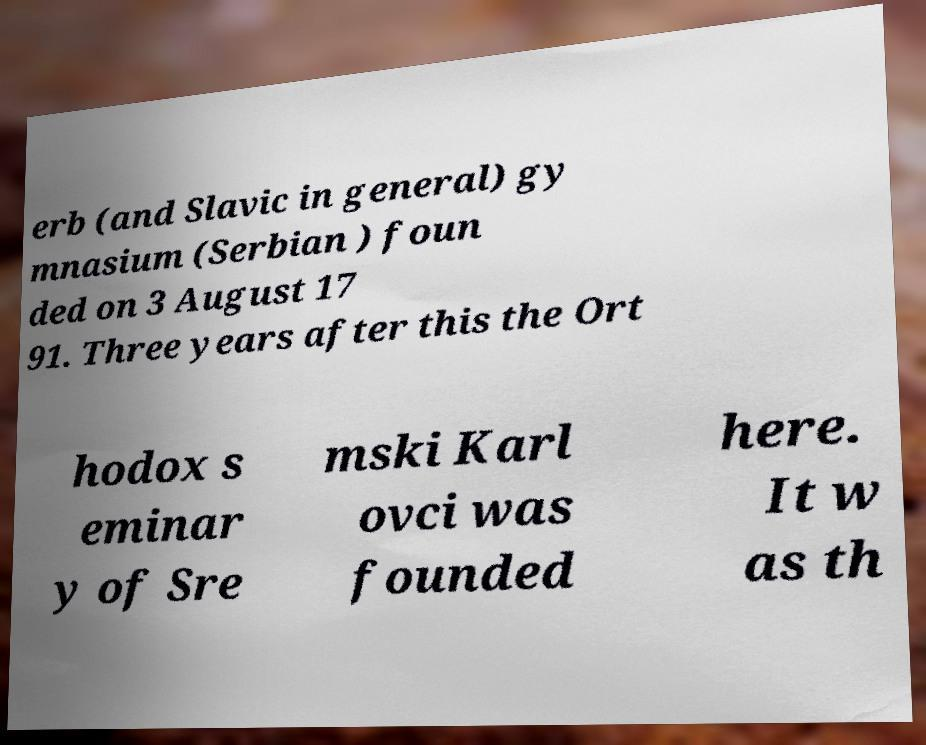I need the written content from this picture converted into text. Can you do that? erb (and Slavic in general) gy mnasium (Serbian ) foun ded on 3 August 17 91. Three years after this the Ort hodox s eminar y of Sre mski Karl ovci was founded here. It w as th 